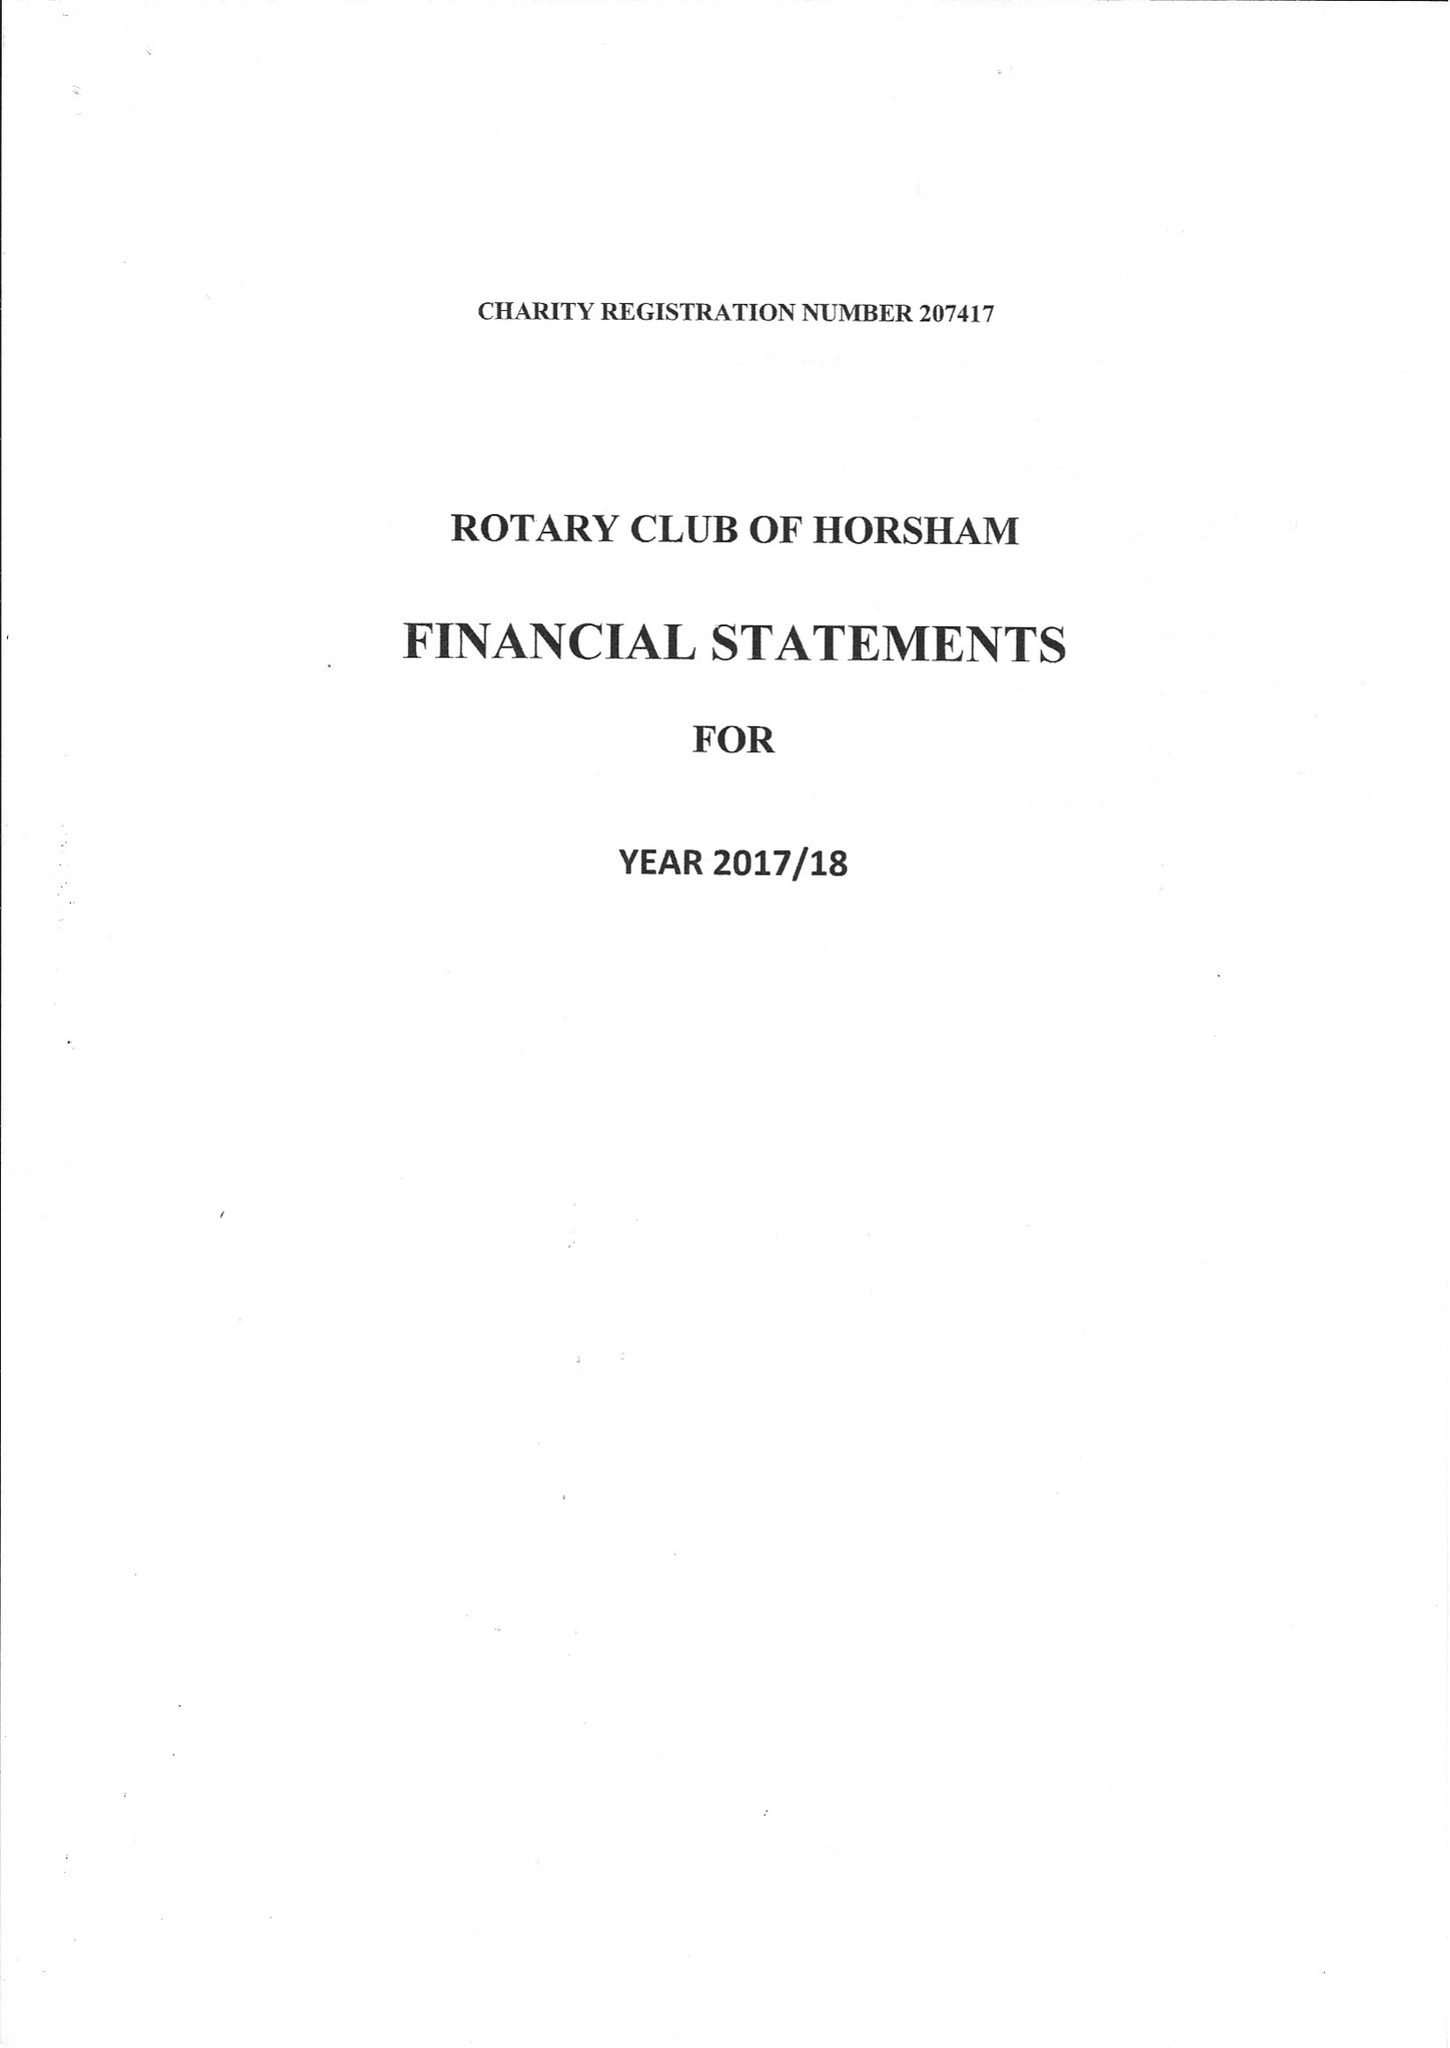What is the value for the charity_name?
Answer the question using a single word or phrase. The Rotary Club Of Horsham Benevolent Fund 